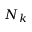Convert formula to latex. <formula><loc_0><loc_0><loc_500><loc_500>N _ { k }</formula> 